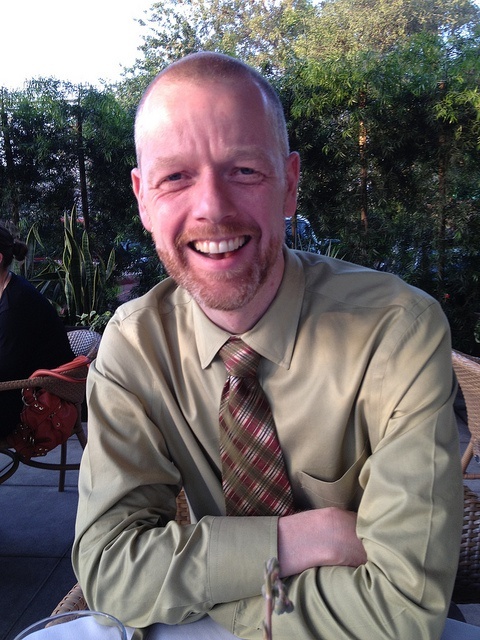Describe the objects in this image and their specific colors. I can see people in white, gray, darkgray, black, and lightpink tones, tie in white, black, gray, and maroon tones, chair in white, black, gray, and maroon tones, people in white, black, gray, and maroon tones, and cup in white, lavender, darkgray, and gray tones in this image. 